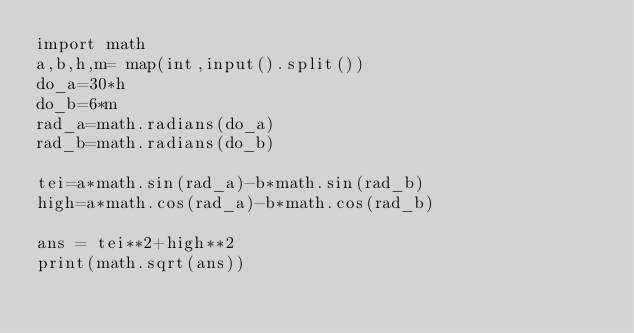<code> <loc_0><loc_0><loc_500><loc_500><_Python_>import math
a,b,h,m= map(int,input().split())
do_a=30*h
do_b=6*m
rad_a=math.radians(do_a)
rad_b=math.radians(do_b)

tei=a*math.sin(rad_a)-b*math.sin(rad_b)
high=a*math.cos(rad_a)-b*math.cos(rad_b)

ans = tei**2+high**2
print(math.sqrt(ans))</code> 